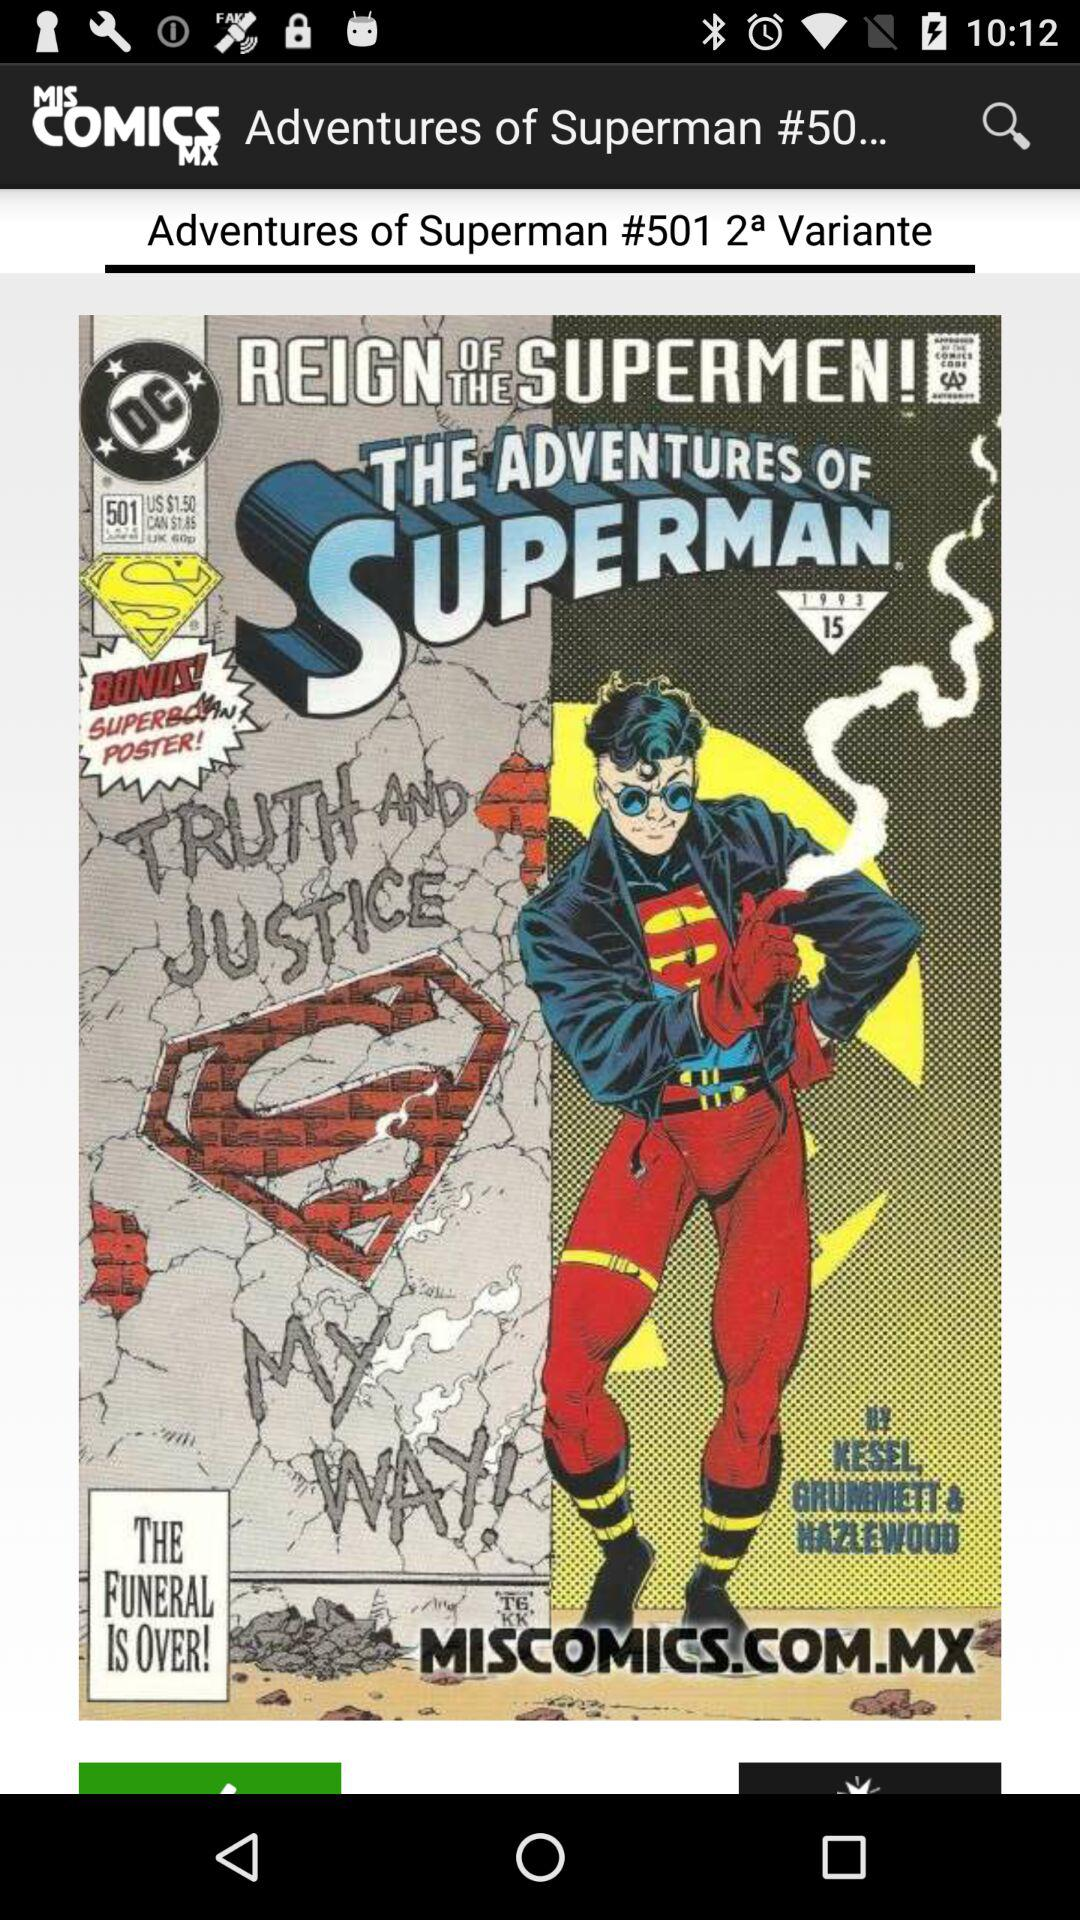What is the name of the comic? The comic name is "Adventures of Superman". 